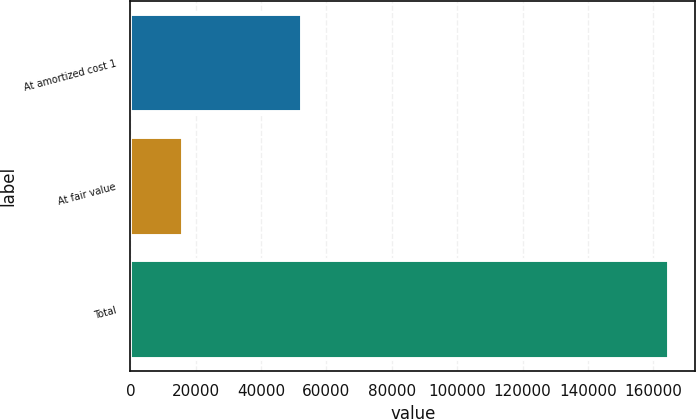Convert chart. <chart><loc_0><loc_0><loc_500><loc_500><bar_chart><fcel>At amortized cost 1<fcel>At fair value<fcel>Total<nl><fcel>52448<fcel>16194<fcel>164681<nl></chart> 